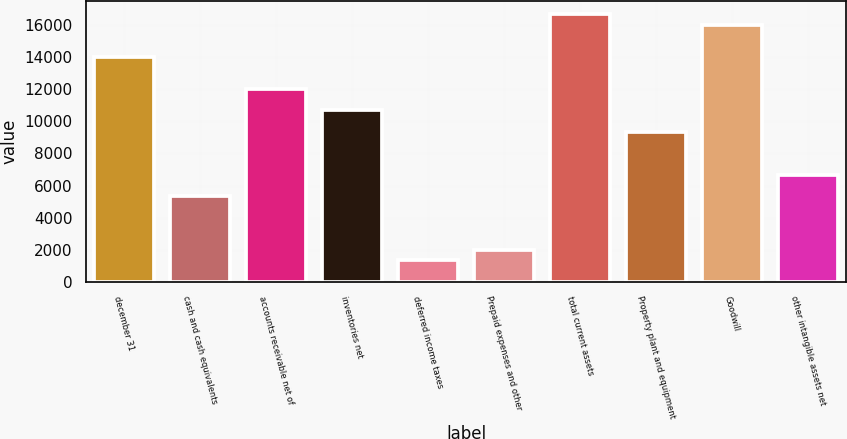Convert chart to OTSL. <chart><loc_0><loc_0><loc_500><loc_500><bar_chart><fcel>december 31<fcel>cash and cash equivalents<fcel>accounts receivable net of<fcel>inventories net<fcel>deferred income taxes<fcel>Prepaid expenses and other<fcel>total current assets<fcel>Property plant and equipment<fcel>Goodwill<fcel>other intangible assets net<nl><fcel>14017.3<fcel>5349.38<fcel>12017<fcel>10683.5<fcel>1348.82<fcel>2015.58<fcel>16684.3<fcel>9349.94<fcel>16017.5<fcel>6682.9<nl></chart> 